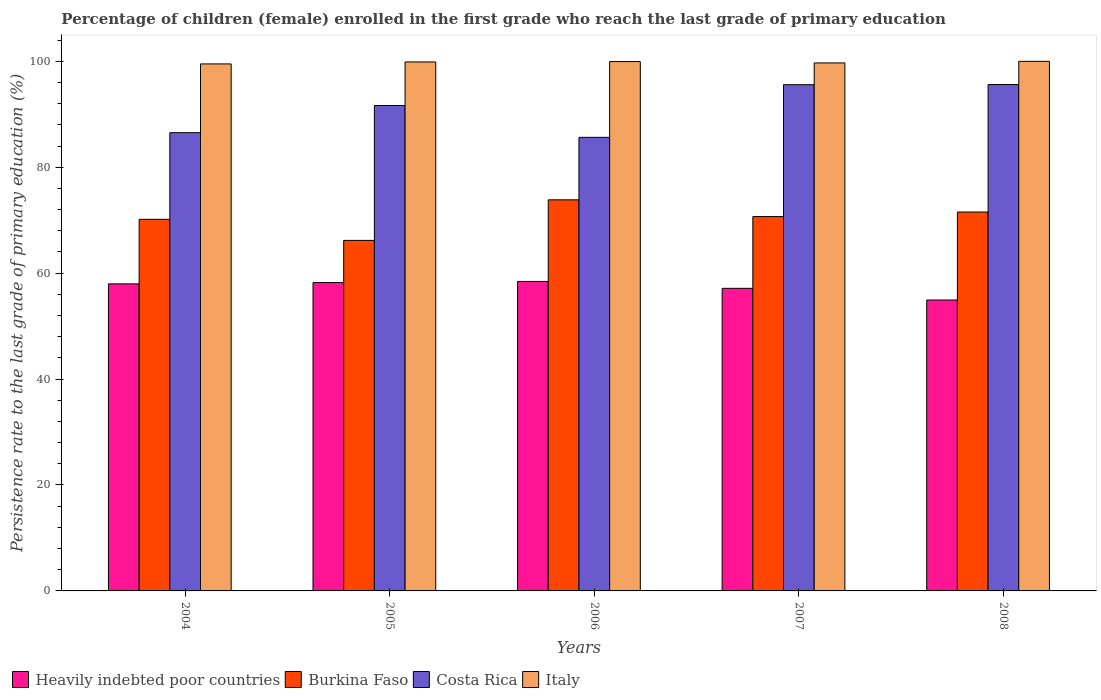How many different coloured bars are there?
Give a very brief answer. 4. How many groups of bars are there?
Give a very brief answer. 5. What is the label of the 4th group of bars from the left?
Your answer should be compact. 2007. What is the persistence rate of children in Heavily indebted poor countries in 2006?
Provide a short and direct response. 58.43. Across all years, what is the maximum persistence rate of children in Costa Rica?
Your answer should be very brief. 95.61. Across all years, what is the minimum persistence rate of children in Burkina Faso?
Provide a succinct answer. 66.18. In which year was the persistence rate of children in Costa Rica minimum?
Your answer should be very brief. 2006. What is the total persistence rate of children in Italy in the graph?
Your answer should be very brief. 499. What is the difference between the persistence rate of children in Italy in 2005 and that in 2008?
Offer a very short reply. -0.11. What is the difference between the persistence rate of children in Heavily indebted poor countries in 2005 and the persistence rate of children in Burkina Faso in 2004?
Your answer should be very brief. -11.94. What is the average persistence rate of children in Heavily indebted poor countries per year?
Offer a very short reply. 57.34. In the year 2006, what is the difference between the persistence rate of children in Italy and persistence rate of children in Costa Rica?
Provide a succinct answer. 14.31. What is the ratio of the persistence rate of children in Burkina Faso in 2006 to that in 2007?
Make the answer very short. 1.04. What is the difference between the highest and the second highest persistence rate of children in Costa Rica?
Offer a terse response. 0.03. What is the difference between the highest and the lowest persistence rate of children in Italy?
Give a very brief answer. 0.48. In how many years, is the persistence rate of children in Heavily indebted poor countries greater than the average persistence rate of children in Heavily indebted poor countries taken over all years?
Your answer should be very brief. 3. Is it the case that in every year, the sum of the persistence rate of children in Burkina Faso and persistence rate of children in Costa Rica is greater than the sum of persistence rate of children in Heavily indebted poor countries and persistence rate of children in Italy?
Provide a succinct answer. No. What does the 4th bar from the left in 2008 represents?
Keep it short and to the point. Italy. Is it the case that in every year, the sum of the persistence rate of children in Italy and persistence rate of children in Heavily indebted poor countries is greater than the persistence rate of children in Burkina Faso?
Offer a very short reply. Yes. What is the difference between two consecutive major ticks on the Y-axis?
Keep it short and to the point. 20. Are the values on the major ticks of Y-axis written in scientific E-notation?
Give a very brief answer. No. Where does the legend appear in the graph?
Your answer should be compact. Bottom left. How many legend labels are there?
Make the answer very short. 4. How are the legend labels stacked?
Keep it short and to the point. Horizontal. What is the title of the graph?
Give a very brief answer. Percentage of children (female) enrolled in the first grade who reach the last grade of primary education. What is the label or title of the Y-axis?
Your answer should be compact. Persistence rate to the last grade of primary education (%). What is the Persistence rate to the last grade of primary education (%) in Heavily indebted poor countries in 2004?
Give a very brief answer. 57.97. What is the Persistence rate to the last grade of primary education (%) of Burkina Faso in 2004?
Your answer should be very brief. 70.16. What is the Persistence rate to the last grade of primary education (%) in Costa Rica in 2004?
Ensure brevity in your answer.  86.52. What is the Persistence rate to the last grade of primary education (%) in Italy in 2004?
Offer a terse response. 99.5. What is the Persistence rate to the last grade of primary education (%) in Heavily indebted poor countries in 2005?
Give a very brief answer. 58.22. What is the Persistence rate to the last grade of primary education (%) in Burkina Faso in 2005?
Offer a terse response. 66.18. What is the Persistence rate to the last grade of primary education (%) of Costa Rica in 2005?
Your answer should be very brief. 91.65. What is the Persistence rate to the last grade of primary education (%) of Italy in 2005?
Provide a succinct answer. 99.88. What is the Persistence rate to the last grade of primary education (%) in Heavily indebted poor countries in 2006?
Make the answer very short. 58.43. What is the Persistence rate to the last grade of primary education (%) of Burkina Faso in 2006?
Make the answer very short. 73.84. What is the Persistence rate to the last grade of primary education (%) in Costa Rica in 2006?
Keep it short and to the point. 85.64. What is the Persistence rate to the last grade of primary education (%) of Italy in 2006?
Keep it short and to the point. 99.95. What is the Persistence rate to the last grade of primary education (%) of Heavily indebted poor countries in 2007?
Offer a very short reply. 57.13. What is the Persistence rate to the last grade of primary education (%) in Burkina Faso in 2007?
Your answer should be very brief. 70.68. What is the Persistence rate to the last grade of primary education (%) in Costa Rica in 2007?
Offer a terse response. 95.58. What is the Persistence rate to the last grade of primary education (%) in Italy in 2007?
Your answer should be compact. 99.69. What is the Persistence rate to the last grade of primary education (%) of Heavily indebted poor countries in 2008?
Ensure brevity in your answer.  54.93. What is the Persistence rate to the last grade of primary education (%) in Burkina Faso in 2008?
Make the answer very short. 71.54. What is the Persistence rate to the last grade of primary education (%) in Costa Rica in 2008?
Your response must be concise. 95.61. What is the Persistence rate to the last grade of primary education (%) of Italy in 2008?
Offer a terse response. 99.99. Across all years, what is the maximum Persistence rate to the last grade of primary education (%) in Heavily indebted poor countries?
Your answer should be compact. 58.43. Across all years, what is the maximum Persistence rate to the last grade of primary education (%) in Burkina Faso?
Keep it short and to the point. 73.84. Across all years, what is the maximum Persistence rate to the last grade of primary education (%) in Costa Rica?
Your answer should be very brief. 95.61. Across all years, what is the maximum Persistence rate to the last grade of primary education (%) in Italy?
Your response must be concise. 99.99. Across all years, what is the minimum Persistence rate to the last grade of primary education (%) in Heavily indebted poor countries?
Give a very brief answer. 54.93. Across all years, what is the minimum Persistence rate to the last grade of primary education (%) in Burkina Faso?
Give a very brief answer. 66.18. Across all years, what is the minimum Persistence rate to the last grade of primary education (%) of Costa Rica?
Offer a very short reply. 85.64. Across all years, what is the minimum Persistence rate to the last grade of primary education (%) of Italy?
Your answer should be very brief. 99.5. What is the total Persistence rate to the last grade of primary education (%) of Heavily indebted poor countries in the graph?
Make the answer very short. 286.69. What is the total Persistence rate to the last grade of primary education (%) in Burkina Faso in the graph?
Provide a short and direct response. 352.4. What is the total Persistence rate to the last grade of primary education (%) in Costa Rica in the graph?
Provide a succinct answer. 454.99. What is the total Persistence rate to the last grade of primary education (%) of Italy in the graph?
Provide a short and direct response. 499. What is the difference between the Persistence rate to the last grade of primary education (%) in Heavily indebted poor countries in 2004 and that in 2005?
Provide a succinct answer. -0.25. What is the difference between the Persistence rate to the last grade of primary education (%) in Burkina Faso in 2004 and that in 2005?
Your answer should be very brief. 3.98. What is the difference between the Persistence rate to the last grade of primary education (%) of Costa Rica in 2004 and that in 2005?
Offer a very short reply. -5.13. What is the difference between the Persistence rate to the last grade of primary education (%) of Italy in 2004 and that in 2005?
Your answer should be compact. -0.37. What is the difference between the Persistence rate to the last grade of primary education (%) in Heavily indebted poor countries in 2004 and that in 2006?
Give a very brief answer. -0.46. What is the difference between the Persistence rate to the last grade of primary education (%) of Burkina Faso in 2004 and that in 2006?
Ensure brevity in your answer.  -3.68. What is the difference between the Persistence rate to the last grade of primary education (%) of Costa Rica in 2004 and that in 2006?
Give a very brief answer. 0.89. What is the difference between the Persistence rate to the last grade of primary education (%) of Italy in 2004 and that in 2006?
Your answer should be compact. -0.44. What is the difference between the Persistence rate to the last grade of primary education (%) of Heavily indebted poor countries in 2004 and that in 2007?
Provide a succinct answer. 0.84. What is the difference between the Persistence rate to the last grade of primary education (%) in Burkina Faso in 2004 and that in 2007?
Your answer should be compact. -0.52. What is the difference between the Persistence rate to the last grade of primary education (%) of Costa Rica in 2004 and that in 2007?
Provide a short and direct response. -9.06. What is the difference between the Persistence rate to the last grade of primary education (%) of Italy in 2004 and that in 2007?
Your answer should be compact. -0.19. What is the difference between the Persistence rate to the last grade of primary education (%) of Heavily indebted poor countries in 2004 and that in 2008?
Keep it short and to the point. 3.05. What is the difference between the Persistence rate to the last grade of primary education (%) of Burkina Faso in 2004 and that in 2008?
Provide a short and direct response. -1.38. What is the difference between the Persistence rate to the last grade of primary education (%) of Costa Rica in 2004 and that in 2008?
Ensure brevity in your answer.  -9.09. What is the difference between the Persistence rate to the last grade of primary education (%) of Italy in 2004 and that in 2008?
Provide a succinct answer. -0.48. What is the difference between the Persistence rate to the last grade of primary education (%) in Heavily indebted poor countries in 2005 and that in 2006?
Make the answer very short. -0.21. What is the difference between the Persistence rate to the last grade of primary education (%) in Burkina Faso in 2005 and that in 2006?
Offer a terse response. -7.66. What is the difference between the Persistence rate to the last grade of primary education (%) of Costa Rica in 2005 and that in 2006?
Your answer should be very brief. 6.01. What is the difference between the Persistence rate to the last grade of primary education (%) of Italy in 2005 and that in 2006?
Ensure brevity in your answer.  -0.07. What is the difference between the Persistence rate to the last grade of primary education (%) of Heavily indebted poor countries in 2005 and that in 2007?
Give a very brief answer. 1.09. What is the difference between the Persistence rate to the last grade of primary education (%) in Burkina Faso in 2005 and that in 2007?
Keep it short and to the point. -4.5. What is the difference between the Persistence rate to the last grade of primary education (%) in Costa Rica in 2005 and that in 2007?
Provide a succinct answer. -3.93. What is the difference between the Persistence rate to the last grade of primary education (%) in Italy in 2005 and that in 2007?
Ensure brevity in your answer.  0.18. What is the difference between the Persistence rate to the last grade of primary education (%) of Heavily indebted poor countries in 2005 and that in 2008?
Provide a short and direct response. 3.3. What is the difference between the Persistence rate to the last grade of primary education (%) in Burkina Faso in 2005 and that in 2008?
Your response must be concise. -5.36. What is the difference between the Persistence rate to the last grade of primary education (%) of Costa Rica in 2005 and that in 2008?
Make the answer very short. -3.96. What is the difference between the Persistence rate to the last grade of primary education (%) in Italy in 2005 and that in 2008?
Make the answer very short. -0.11. What is the difference between the Persistence rate to the last grade of primary education (%) in Heavily indebted poor countries in 2006 and that in 2007?
Give a very brief answer. 1.3. What is the difference between the Persistence rate to the last grade of primary education (%) of Burkina Faso in 2006 and that in 2007?
Keep it short and to the point. 3.16. What is the difference between the Persistence rate to the last grade of primary education (%) in Costa Rica in 2006 and that in 2007?
Give a very brief answer. -9.94. What is the difference between the Persistence rate to the last grade of primary education (%) of Italy in 2006 and that in 2007?
Provide a succinct answer. 0.25. What is the difference between the Persistence rate to the last grade of primary education (%) in Heavily indebted poor countries in 2006 and that in 2008?
Your answer should be very brief. 3.51. What is the difference between the Persistence rate to the last grade of primary education (%) of Burkina Faso in 2006 and that in 2008?
Provide a short and direct response. 2.3. What is the difference between the Persistence rate to the last grade of primary education (%) in Costa Rica in 2006 and that in 2008?
Offer a very short reply. -9.97. What is the difference between the Persistence rate to the last grade of primary education (%) of Italy in 2006 and that in 2008?
Your response must be concise. -0.04. What is the difference between the Persistence rate to the last grade of primary education (%) of Heavily indebted poor countries in 2007 and that in 2008?
Ensure brevity in your answer.  2.21. What is the difference between the Persistence rate to the last grade of primary education (%) in Burkina Faso in 2007 and that in 2008?
Your answer should be compact. -0.86. What is the difference between the Persistence rate to the last grade of primary education (%) in Costa Rica in 2007 and that in 2008?
Offer a terse response. -0.03. What is the difference between the Persistence rate to the last grade of primary education (%) of Italy in 2007 and that in 2008?
Your answer should be very brief. -0.29. What is the difference between the Persistence rate to the last grade of primary education (%) in Heavily indebted poor countries in 2004 and the Persistence rate to the last grade of primary education (%) in Burkina Faso in 2005?
Offer a very short reply. -8.21. What is the difference between the Persistence rate to the last grade of primary education (%) in Heavily indebted poor countries in 2004 and the Persistence rate to the last grade of primary education (%) in Costa Rica in 2005?
Give a very brief answer. -33.67. What is the difference between the Persistence rate to the last grade of primary education (%) of Heavily indebted poor countries in 2004 and the Persistence rate to the last grade of primary education (%) of Italy in 2005?
Make the answer very short. -41.9. What is the difference between the Persistence rate to the last grade of primary education (%) of Burkina Faso in 2004 and the Persistence rate to the last grade of primary education (%) of Costa Rica in 2005?
Your answer should be very brief. -21.49. What is the difference between the Persistence rate to the last grade of primary education (%) of Burkina Faso in 2004 and the Persistence rate to the last grade of primary education (%) of Italy in 2005?
Your answer should be compact. -29.71. What is the difference between the Persistence rate to the last grade of primary education (%) in Costa Rica in 2004 and the Persistence rate to the last grade of primary education (%) in Italy in 2005?
Offer a terse response. -13.35. What is the difference between the Persistence rate to the last grade of primary education (%) of Heavily indebted poor countries in 2004 and the Persistence rate to the last grade of primary education (%) of Burkina Faso in 2006?
Offer a terse response. -15.87. What is the difference between the Persistence rate to the last grade of primary education (%) in Heavily indebted poor countries in 2004 and the Persistence rate to the last grade of primary education (%) in Costa Rica in 2006?
Provide a succinct answer. -27.66. What is the difference between the Persistence rate to the last grade of primary education (%) in Heavily indebted poor countries in 2004 and the Persistence rate to the last grade of primary education (%) in Italy in 2006?
Ensure brevity in your answer.  -41.97. What is the difference between the Persistence rate to the last grade of primary education (%) of Burkina Faso in 2004 and the Persistence rate to the last grade of primary education (%) of Costa Rica in 2006?
Provide a succinct answer. -15.47. What is the difference between the Persistence rate to the last grade of primary education (%) of Burkina Faso in 2004 and the Persistence rate to the last grade of primary education (%) of Italy in 2006?
Provide a succinct answer. -29.78. What is the difference between the Persistence rate to the last grade of primary education (%) in Costa Rica in 2004 and the Persistence rate to the last grade of primary education (%) in Italy in 2006?
Give a very brief answer. -13.42. What is the difference between the Persistence rate to the last grade of primary education (%) of Heavily indebted poor countries in 2004 and the Persistence rate to the last grade of primary education (%) of Burkina Faso in 2007?
Provide a short and direct response. -12.71. What is the difference between the Persistence rate to the last grade of primary education (%) in Heavily indebted poor countries in 2004 and the Persistence rate to the last grade of primary education (%) in Costa Rica in 2007?
Keep it short and to the point. -37.61. What is the difference between the Persistence rate to the last grade of primary education (%) in Heavily indebted poor countries in 2004 and the Persistence rate to the last grade of primary education (%) in Italy in 2007?
Your response must be concise. -41.72. What is the difference between the Persistence rate to the last grade of primary education (%) in Burkina Faso in 2004 and the Persistence rate to the last grade of primary education (%) in Costa Rica in 2007?
Your response must be concise. -25.42. What is the difference between the Persistence rate to the last grade of primary education (%) in Burkina Faso in 2004 and the Persistence rate to the last grade of primary education (%) in Italy in 2007?
Ensure brevity in your answer.  -29.53. What is the difference between the Persistence rate to the last grade of primary education (%) of Costa Rica in 2004 and the Persistence rate to the last grade of primary education (%) of Italy in 2007?
Provide a short and direct response. -13.17. What is the difference between the Persistence rate to the last grade of primary education (%) in Heavily indebted poor countries in 2004 and the Persistence rate to the last grade of primary education (%) in Burkina Faso in 2008?
Your response must be concise. -13.57. What is the difference between the Persistence rate to the last grade of primary education (%) in Heavily indebted poor countries in 2004 and the Persistence rate to the last grade of primary education (%) in Costa Rica in 2008?
Give a very brief answer. -37.64. What is the difference between the Persistence rate to the last grade of primary education (%) of Heavily indebted poor countries in 2004 and the Persistence rate to the last grade of primary education (%) of Italy in 2008?
Your answer should be compact. -42.01. What is the difference between the Persistence rate to the last grade of primary education (%) of Burkina Faso in 2004 and the Persistence rate to the last grade of primary education (%) of Costa Rica in 2008?
Your answer should be compact. -25.45. What is the difference between the Persistence rate to the last grade of primary education (%) of Burkina Faso in 2004 and the Persistence rate to the last grade of primary education (%) of Italy in 2008?
Your response must be concise. -29.82. What is the difference between the Persistence rate to the last grade of primary education (%) of Costa Rica in 2004 and the Persistence rate to the last grade of primary education (%) of Italy in 2008?
Keep it short and to the point. -13.47. What is the difference between the Persistence rate to the last grade of primary education (%) in Heavily indebted poor countries in 2005 and the Persistence rate to the last grade of primary education (%) in Burkina Faso in 2006?
Make the answer very short. -15.62. What is the difference between the Persistence rate to the last grade of primary education (%) in Heavily indebted poor countries in 2005 and the Persistence rate to the last grade of primary education (%) in Costa Rica in 2006?
Provide a short and direct response. -27.41. What is the difference between the Persistence rate to the last grade of primary education (%) of Heavily indebted poor countries in 2005 and the Persistence rate to the last grade of primary education (%) of Italy in 2006?
Your answer should be compact. -41.72. What is the difference between the Persistence rate to the last grade of primary education (%) of Burkina Faso in 2005 and the Persistence rate to the last grade of primary education (%) of Costa Rica in 2006?
Offer a terse response. -19.46. What is the difference between the Persistence rate to the last grade of primary education (%) in Burkina Faso in 2005 and the Persistence rate to the last grade of primary education (%) in Italy in 2006?
Provide a succinct answer. -33.76. What is the difference between the Persistence rate to the last grade of primary education (%) of Costa Rica in 2005 and the Persistence rate to the last grade of primary education (%) of Italy in 2006?
Keep it short and to the point. -8.3. What is the difference between the Persistence rate to the last grade of primary education (%) of Heavily indebted poor countries in 2005 and the Persistence rate to the last grade of primary education (%) of Burkina Faso in 2007?
Offer a very short reply. -12.46. What is the difference between the Persistence rate to the last grade of primary education (%) in Heavily indebted poor countries in 2005 and the Persistence rate to the last grade of primary education (%) in Costa Rica in 2007?
Your answer should be very brief. -37.36. What is the difference between the Persistence rate to the last grade of primary education (%) in Heavily indebted poor countries in 2005 and the Persistence rate to the last grade of primary education (%) in Italy in 2007?
Provide a short and direct response. -41.47. What is the difference between the Persistence rate to the last grade of primary education (%) in Burkina Faso in 2005 and the Persistence rate to the last grade of primary education (%) in Costa Rica in 2007?
Ensure brevity in your answer.  -29.4. What is the difference between the Persistence rate to the last grade of primary education (%) in Burkina Faso in 2005 and the Persistence rate to the last grade of primary education (%) in Italy in 2007?
Your answer should be compact. -33.51. What is the difference between the Persistence rate to the last grade of primary education (%) of Costa Rica in 2005 and the Persistence rate to the last grade of primary education (%) of Italy in 2007?
Your answer should be compact. -8.04. What is the difference between the Persistence rate to the last grade of primary education (%) in Heavily indebted poor countries in 2005 and the Persistence rate to the last grade of primary education (%) in Burkina Faso in 2008?
Your answer should be compact. -13.32. What is the difference between the Persistence rate to the last grade of primary education (%) of Heavily indebted poor countries in 2005 and the Persistence rate to the last grade of primary education (%) of Costa Rica in 2008?
Provide a succinct answer. -37.39. What is the difference between the Persistence rate to the last grade of primary education (%) in Heavily indebted poor countries in 2005 and the Persistence rate to the last grade of primary education (%) in Italy in 2008?
Ensure brevity in your answer.  -41.76. What is the difference between the Persistence rate to the last grade of primary education (%) in Burkina Faso in 2005 and the Persistence rate to the last grade of primary education (%) in Costa Rica in 2008?
Provide a short and direct response. -29.43. What is the difference between the Persistence rate to the last grade of primary education (%) of Burkina Faso in 2005 and the Persistence rate to the last grade of primary education (%) of Italy in 2008?
Your response must be concise. -33.81. What is the difference between the Persistence rate to the last grade of primary education (%) of Costa Rica in 2005 and the Persistence rate to the last grade of primary education (%) of Italy in 2008?
Offer a very short reply. -8.34. What is the difference between the Persistence rate to the last grade of primary education (%) of Heavily indebted poor countries in 2006 and the Persistence rate to the last grade of primary education (%) of Burkina Faso in 2007?
Keep it short and to the point. -12.25. What is the difference between the Persistence rate to the last grade of primary education (%) in Heavily indebted poor countries in 2006 and the Persistence rate to the last grade of primary education (%) in Costa Rica in 2007?
Your answer should be very brief. -37.15. What is the difference between the Persistence rate to the last grade of primary education (%) in Heavily indebted poor countries in 2006 and the Persistence rate to the last grade of primary education (%) in Italy in 2007?
Keep it short and to the point. -41.26. What is the difference between the Persistence rate to the last grade of primary education (%) of Burkina Faso in 2006 and the Persistence rate to the last grade of primary education (%) of Costa Rica in 2007?
Keep it short and to the point. -21.74. What is the difference between the Persistence rate to the last grade of primary education (%) in Burkina Faso in 2006 and the Persistence rate to the last grade of primary education (%) in Italy in 2007?
Give a very brief answer. -25.85. What is the difference between the Persistence rate to the last grade of primary education (%) of Costa Rica in 2006 and the Persistence rate to the last grade of primary education (%) of Italy in 2007?
Give a very brief answer. -14.06. What is the difference between the Persistence rate to the last grade of primary education (%) of Heavily indebted poor countries in 2006 and the Persistence rate to the last grade of primary education (%) of Burkina Faso in 2008?
Your response must be concise. -13.11. What is the difference between the Persistence rate to the last grade of primary education (%) in Heavily indebted poor countries in 2006 and the Persistence rate to the last grade of primary education (%) in Costa Rica in 2008?
Make the answer very short. -37.18. What is the difference between the Persistence rate to the last grade of primary education (%) in Heavily indebted poor countries in 2006 and the Persistence rate to the last grade of primary education (%) in Italy in 2008?
Provide a short and direct response. -41.55. What is the difference between the Persistence rate to the last grade of primary education (%) in Burkina Faso in 2006 and the Persistence rate to the last grade of primary education (%) in Costa Rica in 2008?
Your response must be concise. -21.77. What is the difference between the Persistence rate to the last grade of primary education (%) of Burkina Faso in 2006 and the Persistence rate to the last grade of primary education (%) of Italy in 2008?
Your response must be concise. -26.14. What is the difference between the Persistence rate to the last grade of primary education (%) in Costa Rica in 2006 and the Persistence rate to the last grade of primary education (%) in Italy in 2008?
Your response must be concise. -14.35. What is the difference between the Persistence rate to the last grade of primary education (%) of Heavily indebted poor countries in 2007 and the Persistence rate to the last grade of primary education (%) of Burkina Faso in 2008?
Keep it short and to the point. -14.41. What is the difference between the Persistence rate to the last grade of primary education (%) of Heavily indebted poor countries in 2007 and the Persistence rate to the last grade of primary education (%) of Costa Rica in 2008?
Your answer should be very brief. -38.48. What is the difference between the Persistence rate to the last grade of primary education (%) of Heavily indebted poor countries in 2007 and the Persistence rate to the last grade of primary education (%) of Italy in 2008?
Your answer should be compact. -42.86. What is the difference between the Persistence rate to the last grade of primary education (%) in Burkina Faso in 2007 and the Persistence rate to the last grade of primary education (%) in Costa Rica in 2008?
Ensure brevity in your answer.  -24.93. What is the difference between the Persistence rate to the last grade of primary education (%) of Burkina Faso in 2007 and the Persistence rate to the last grade of primary education (%) of Italy in 2008?
Make the answer very short. -29.31. What is the difference between the Persistence rate to the last grade of primary education (%) of Costa Rica in 2007 and the Persistence rate to the last grade of primary education (%) of Italy in 2008?
Provide a short and direct response. -4.41. What is the average Persistence rate to the last grade of primary education (%) in Heavily indebted poor countries per year?
Provide a short and direct response. 57.34. What is the average Persistence rate to the last grade of primary education (%) of Burkina Faso per year?
Offer a terse response. 70.48. What is the average Persistence rate to the last grade of primary education (%) in Costa Rica per year?
Your response must be concise. 91. What is the average Persistence rate to the last grade of primary education (%) in Italy per year?
Offer a very short reply. 99.8. In the year 2004, what is the difference between the Persistence rate to the last grade of primary education (%) in Heavily indebted poor countries and Persistence rate to the last grade of primary education (%) in Burkina Faso?
Provide a short and direct response. -12.19. In the year 2004, what is the difference between the Persistence rate to the last grade of primary education (%) of Heavily indebted poor countries and Persistence rate to the last grade of primary education (%) of Costa Rica?
Offer a very short reply. -28.55. In the year 2004, what is the difference between the Persistence rate to the last grade of primary education (%) in Heavily indebted poor countries and Persistence rate to the last grade of primary education (%) in Italy?
Your answer should be very brief. -41.53. In the year 2004, what is the difference between the Persistence rate to the last grade of primary education (%) of Burkina Faso and Persistence rate to the last grade of primary education (%) of Costa Rica?
Make the answer very short. -16.36. In the year 2004, what is the difference between the Persistence rate to the last grade of primary education (%) in Burkina Faso and Persistence rate to the last grade of primary education (%) in Italy?
Provide a succinct answer. -29.34. In the year 2004, what is the difference between the Persistence rate to the last grade of primary education (%) in Costa Rica and Persistence rate to the last grade of primary education (%) in Italy?
Provide a succinct answer. -12.98. In the year 2005, what is the difference between the Persistence rate to the last grade of primary education (%) of Heavily indebted poor countries and Persistence rate to the last grade of primary education (%) of Burkina Faso?
Ensure brevity in your answer.  -7.96. In the year 2005, what is the difference between the Persistence rate to the last grade of primary education (%) in Heavily indebted poor countries and Persistence rate to the last grade of primary education (%) in Costa Rica?
Ensure brevity in your answer.  -33.42. In the year 2005, what is the difference between the Persistence rate to the last grade of primary education (%) of Heavily indebted poor countries and Persistence rate to the last grade of primary education (%) of Italy?
Provide a succinct answer. -41.65. In the year 2005, what is the difference between the Persistence rate to the last grade of primary education (%) of Burkina Faso and Persistence rate to the last grade of primary education (%) of Costa Rica?
Give a very brief answer. -25.47. In the year 2005, what is the difference between the Persistence rate to the last grade of primary education (%) of Burkina Faso and Persistence rate to the last grade of primary education (%) of Italy?
Make the answer very short. -33.69. In the year 2005, what is the difference between the Persistence rate to the last grade of primary education (%) in Costa Rica and Persistence rate to the last grade of primary education (%) in Italy?
Your response must be concise. -8.23. In the year 2006, what is the difference between the Persistence rate to the last grade of primary education (%) of Heavily indebted poor countries and Persistence rate to the last grade of primary education (%) of Burkina Faso?
Keep it short and to the point. -15.41. In the year 2006, what is the difference between the Persistence rate to the last grade of primary education (%) of Heavily indebted poor countries and Persistence rate to the last grade of primary education (%) of Costa Rica?
Offer a terse response. -27.2. In the year 2006, what is the difference between the Persistence rate to the last grade of primary education (%) in Heavily indebted poor countries and Persistence rate to the last grade of primary education (%) in Italy?
Provide a succinct answer. -41.51. In the year 2006, what is the difference between the Persistence rate to the last grade of primary education (%) in Burkina Faso and Persistence rate to the last grade of primary education (%) in Costa Rica?
Your answer should be compact. -11.79. In the year 2006, what is the difference between the Persistence rate to the last grade of primary education (%) of Burkina Faso and Persistence rate to the last grade of primary education (%) of Italy?
Your answer should be compact. -26.1. In the year 2006, what is the difference between the Persistence rate to the last grade of primary education (%) of Costa Rica and Persistence rate to the last grade of primary education (%) of Italy?
Provide a short and direct response. -14.31. In the year 2007, what is the difference between the Persistence rate to the last grade of primary education (%) of Heavily indebted poor countries and Persistence rate to the last grade of primary education (%) of Burkina Faso?
Make the answer very short. -13.55. In the year 2007, what is the difference between the Persistence rate to the last grade of primary education (%) in Heavily indebted poor countries and Persistence rate to the last grade of primary education (%) in Costa Rica?
Keep it short and to the point. -38.45. In the year 2007, what is the difference between the Persistence rate to the last grade of primary education (%) in Heavily indebted poor countries and Persistence rate to the last grade of primary education (%) in Italy?
Give a very brief answer. -42.56. In the year 2007, what is the difference between the Persistence rate to the last grade of primary education (%) of Burkina Faso and Persistence rate to the last grade of primary education (%) of Costa Rica?
Make the answer very short. -24.9. In the year 2007, what is the difference between the Persistence rate to the last grade of primary education (%) of Burkina Faso and Persistence rate to the last grade of primary education (%) of Italy?
Offer a terse response. -29.01. In the year 2007, what is the difference between the Persistence rate to the last grade of primary education (%) in Costa Rica and Persistence rate to the last grade of primary education (%) in Italy?
Your response must be concise. -4.11. In the year 2008, what is the difference between the Persistence rate to the last grade of primary education (%) of Heavily indebted poor countries and Persistence rate to the last grade of primary education (%) of Burkina Faso?
Your answer should be very brief. -16.61. In the year 2008, what is the difference between the Persistence rate to the last grade of primary education (%) of Heavily indebted poor countries and Persistence rate to the last grade of primary education (%) of Costa Rica?
Your answer should be compact. -40.68. In the year 2008, what is the difference between the Persistence rate to the last grade of primary education (%) of Heavily indebted poor countries and Persistence rate to the last grade of primary education (%) of Italy?
Provide a short and direct response. -45.06. In the year 2008, what is the difference between the Persistence rate to the last grade of primary education (%) in Burkina Faso and Persistence rate to the last grade of primary education (%) in Costa Rica?
Your answer should be compact. -24.07. In the year 2008, what is the difference between the Persistence rate to the last grade of primary education (%) in Burkina Faso and Persistence rate to the last grade of primary education (%) in Italy?
Keep it short and to the point. -28.45. In the year 2008, what is the difference between the Persistence rate to the last grade of primary education (%) of Costa Rica and Persistence rate to the last grade of primary education (%) of Italy?
Make the answer very short. -4.38. What is the ratio of the Persistence rate to the last grade of primary education (%) in Burkina Faso in 2004 to that in 2005?
Provide a short and direct response. 1.06. What is the ratio of the Persistence rate to the last grade of primary education (%) in Costa Rica in 2004 to that in 2005?
Make the answer very short. 0.94. What is the ratio of the Persistence rate to the last grade of primary education (%) of Italy in 2004 to that in 2005?
Offer a terse response. 1. What is the ratio of the Persistence rate to the last grade of primary education (%) in Heavily indebted poor countries in 2004 to that in 2006?
Ensure brevity in your answer.  0.99. What is the ratio of the Persistence rate to the last grade of primary education (%) in Burkina Faso in 2004 to that in 2006?
Give a very brief answer. 0.95. What is the ratio of the Persistence rate to the last grade of primary education (%) in Costa Rica in 2004 to that in 2006?
Provide a succinct answer. 1.01. What is the ratio of the Persistence rate to the last grade of primary education (%) of Italy in 2004 to that in 2006?
Give a very brief answer. 1. What is the ratio of the Persistence rate to the last grade of primary education (%) in Heavily indebted poor countries in 2004 to that in 2007?
Your answer should be compact. 1.01. What is the ratio of the Persistence rate to the last grade of primary education (%) in Costa Rica in 2004 to that in 2007?
Ensure brevity in your answer.  0.91. What is the ratio of the Persistence rate to the last grade of primary education (%) of Heavily indebted poor countries in 2004 to that in 2008?
Offer a terse response. 1.06. What is the ratio of the Persistence rate to the last grade of primary education (%) of Burkina Faso in 2004 to that in 2008?
Make the answer very short. 0.98. What is the ratio of the Persistence rate to the last grade of primary education (%) of Costa Rica in 2004 to that in 2008?
Offer a very short reply. 0.9. What is the ratio of the Persistence rate to the last grade of primary education (%) in Italy in 2004 to that in 2008?
Your answer should be very brief. 1. What is the ratio of the Persistence rate to the last grade of primary education (%) of Heavily indebted poor countries in 2005 to that in 2006?
Offer a terse response. 1. What is the ratio of the Persistence rate to the last grade of primary education (%) of Burkina Faso in 2005 to that in 2006?
Offer a terse response. 0.9. What is the ratio of the Persistence rate to the last grade of primary education (%) in Costa Rica in 2005 to that in 2006?
Offer a terse response. 1.07. What is the ratio of the Persistence rate to the last grade of primary education (%) in Italy in 2005 to that in 2006?
Provide a short and direct response. 1. What is the ratio of the Persistence rate to the last grade of primary education (%) in Heavily indebted poor countries in 2005 to that in 2007?
Make the answer very short. 1.02. What is the ratio of the Persistence rate to the last grade of primary education (%) of Burkina Faso in 2005 to that in 2007?
Ensure brevity in your answer.  0.94. What is the ratio of the Persistence rate to the last grade of primary education (%) in Costa Rica in 2005 to that in 2007?
Provide a succinct answer. 0.96. What is the ratio of the Persistence rate to the last grade of primary education (%) of Italy in 2005 to that in 2007?
Your answer should be compact. 1. What is the ratio of the Persistence rate to the last grade of primary education (%) of Heavily indebted poor countries in 2005 to that in 2008?
Ensure brevity in your answer.  1.06. What is the ratio of the Persistence rate to the last grade of primary education (%) of Burkina Faso in 2005 to that in 2008?
Provide a short and direct response. 0.93. What is the ratio of the Persistence rate to the last grade of primary education (%) of Costa Rica in 2005 to that in 2008?
Provide a short and direct response. 0.96. What is the ratio of the Persistence rate to the last grade of primary education (%) in Heavily indebted poor countries in 2006 to that in 2007?
Make the answer very short. 1.02. What is the ratio of the Persistence rate to the last grade of primary education (%) of Burkina Faso in 2006 to that in 2007?
Provide a short and direct response. 1.04. What is the ratio of the Persistence rate to the last grade of primary education (%) of Costa Rica in 2006 to that in 2007?
Provide a short and direct response. 0.9. What is the ratio of the Persistence rate to the last grade of primary education (%) of Italy in 2006 to that in 2007?
Your response must be concise. 1. What is the ratio of the Persistence rate to the last grade of primary education (%) in Heavily indebted poor countries in 2006 to that in 2008?
Give a very brief answer. 1.06. What is the ratio of the Persistence rate to the last grade of primary education (%) of Burkina Faso in 2006 to that in 2008?
Offer a very short reply. 1.03. What is the ratio of the Persistence rate to the last grade of primary education (%) of Costa Rica in 2006 to that in 2008?
Offer a terse response. 0.9. What is the ratio of the Persistence rate to the last grade of primary education (%) of Italy in 2006 to that in 2008?
Offer a terse response. 1. What is the ratio of the Persistence rate to the last grade of primary education (%) in Heavily indebted poor countries in 2007 to that in 2008?
Provide a short and direct response. 1.04. What is the ratio of the Persistence rate to the last grade of primary education (%) in Burkina Faso in 2007 to that in 2008?
Ensure brevity in your answer.  0.99. What is the ratio of the Persistence rate to the last grade of primary education (%) in Costa Rica in 2007 to that in 2008?
Offer a very short reply. 1. What is the difference between the highest and the second highest Persistence rate to the last grade of primary education (%) of Heavily indebted poor countries?
Offer a terse response. 0.21. What is the difference between the highest and the second highest Persistence rate to the last grade of primary education (%) of Burkina Faso?
Ensure brevity in your answer.  2.3. What is the difference between the highest and the second highest Persistence rate to the last grade of primary education (%) of Costa Rica?
Your response must be concise. 0.03. What is the difference between the highest and the second highest Persistence rate to the last grade of primary education (%) in Italy?
Your answer should be very brief. 0.04. What is the difference between the highest and the lowest Persistence rate to the last grade of primary education (%) of Heavily indebted poor countries?
Your response must be concise. 3.51. What is the difference between the highest and the lowest Persistence rate to the last grade of primary education (%) of Burkina Faso?
Make the answer very short. 7.66. What is the difference between the highest and the lowest Persistence rate to the last grade of primary education (%) of Costa Rica?
Your answer should be very brief. 9.97. What is the difference between the highest and the lowest Persistence rate to the last grade of primary education (%) in Italy?
Make the answer very short. 0.48. 